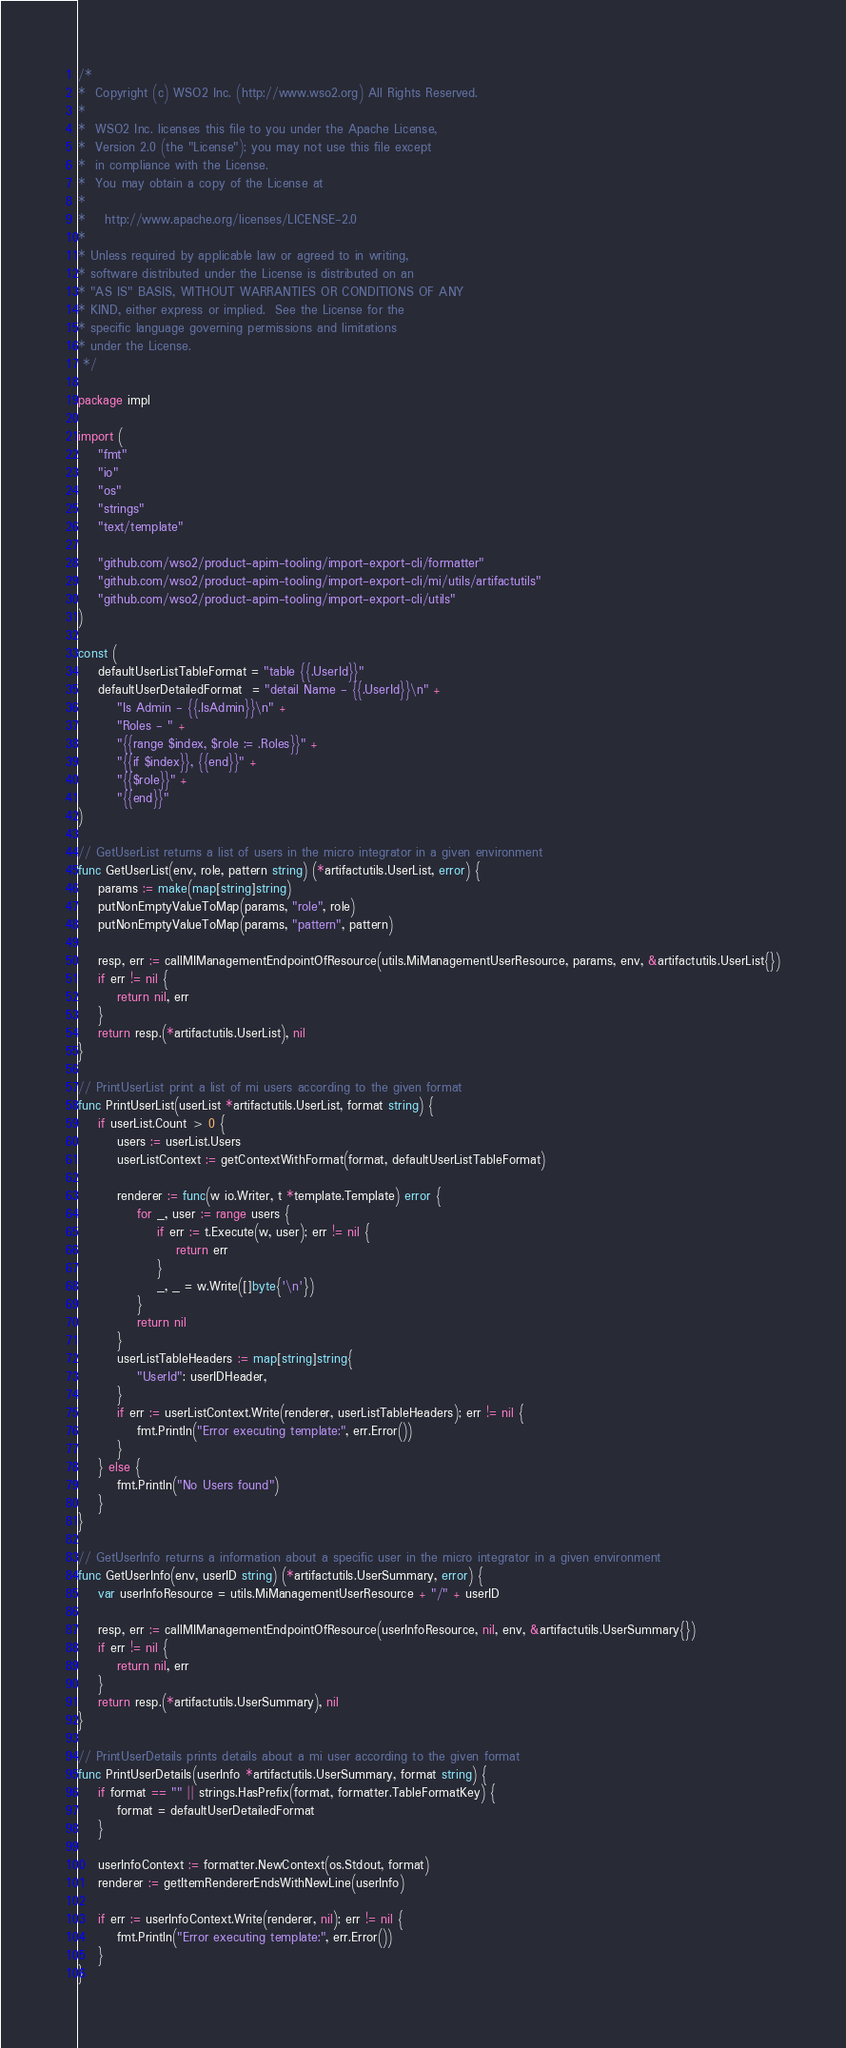Convert code to text. <code><loc_0><loc_0><loc_500><loc_500><_Go_>/*
*  Copyright (c) WSO2 Inc. (http://www.wso2.org) All Rights Reserved.
*
*  WSO2 Inc. licenses this file to you under the Apache License,
*  Version 2.0 (the "License"); you may not use this file except
*  in compliance with the License.
*  You may obtain a copy of the License at
*
*    http://www.apache.org/licenses/LICENSE-2.0
*
* Unless required by applicable law or agreed to in writing,
* software distributed under the License is distributed on an
* "AS IS" BASIS, WITHOUT WARRANTIES OR CONDITIONS OF ANY
* KIND, either express or implied.  See the License for the
* specific language governing permissions and limitations
* under the License.
 */

package impl

import (
	"fmt"
	"io"
	"os"
	"strings"
	"text/template"

	"github.com/wso2/product-apim-tooling/import-export-cli/formatter"
	"github.com/wso2/product-apim-tooling/import-export-cli/mi/utils/artifactutils"
	"github.com/wso2/product-apim-tooling/import-export-cli/utils"
)

const (
	defaultUserListTableFormat = "table {{.UserId}}"
	defaultUserDetailedFormat  = "detail Name - {{.UserId}}\n" +
		"Is Admin - {{.IsAdmin}}\n" +
		"Roles - " +
		"{{range $index, $role := .Roles}}" +
		"{{if $index}}, {{end}}" +
		"{{$role}}" +
		"{{end}}"
)

// GetUserList returns a list of users in the micro integrator in a given environment
func GetUserList(env, role, pattern string) (*artifactutils.UserList, error) {
	params := make(map[string]string)
	putNonEmptyValueToMap(params, "role", role)
	putNonEmptyValueToMap(params, "pattern", pattern)

	resp, err := callMIManagementEndpointOfResource(utils.MiManagementUserResource, params, env, &artifactutils.UserList{})
	if err != nil {
		return nil, err
	}
	return resp.(*artifactutils.UserList), nil
}

// PrintUserList print a list of mi users according to the given format
func PrintUserList(userList *artifactutils.UserList, format string) {
	if userList.Count > 0 {
		users := userList.Users
		userListContext := getContextWithFormat(format, defaultUserListTableFormat)

		renderer := func(w io.Writer, t *template.Template) error {
			for _, user := range users {
				if err := t.Execute(w, user); err != nil {
					return err
				}
				_, _ = w.Write([]byte{'\n'})
			}
			return nil
		}
		userListTableHeaders := map[string]string{
			"UserId": userIDHeader,
		}
		if err := userListContext.Write(renderer, userListTableHeaders); err != nil {
			fmt.Println("Error executing template:", err.Error())
		}
	} else {
		fmt.Println("No Users found")
	}
}

// GetUserInfo returns a information about a specific user in the micro integrator in a given environment
func GetUserInfo(env, userID string) (*artifactutils.UserSummary, error) {
	var userInfoResource = utils.MiManagementUserResource + "/" + userID

	resp, err := callMIManagementEndpointOfResource(userInfoResource, nil, env, &artifactutils.UserSummary{})
	if err != nil {
		return nil, err
	}
	return resp.(*artifactutils.UserSummary), nil
}

// PrintUserDetails prints details about a mi user according to the given format
func PrintUserDetails(userInfo *artifactutils.UserSummary, format string) {
	if format == "" || strings.HasPrefix(format, formatter.TableFormatKey) {
		format = defaultUserDetailedFormat
	}

	userInfoContext := formatter.NewContext(os.Stdout, format)
	renderer := getItemRendererEndsWithNewLine(userInfo)

	if err := userInfoContext.Write(renderer, nil); err != nil {
		fmt.Println("Error executing template:", err.Error())
	}
}
</code> 